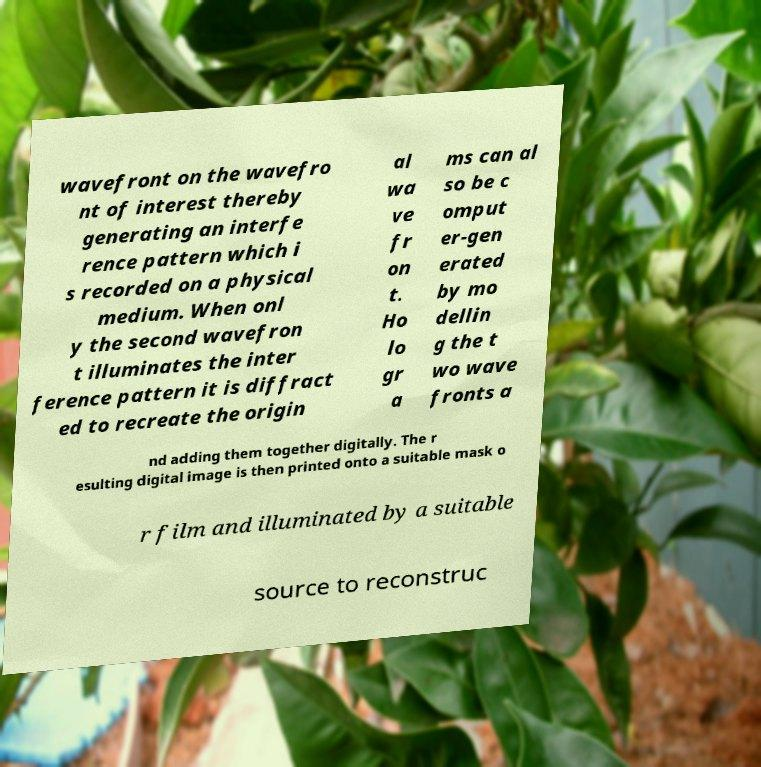What messages or text are displayed in this image? I need them in a readable, typed format. wavefront on the wavefro nt of interest thereby generating an interfe rence pattern which i s recorded on a physical medium. When onl y the second wavefron t illuminates the inter ference pattern it is diffract ed to recreate the origin al wa ve fr on t. Ho lo gr a ms can al so be c omput er-gen erated by mo dellin g the t wo wave fronts a nd adding them together digitally. The r esulting digital image is then printed onto a suitable mask o r film and illuminated by a suitable source to reconstruc 